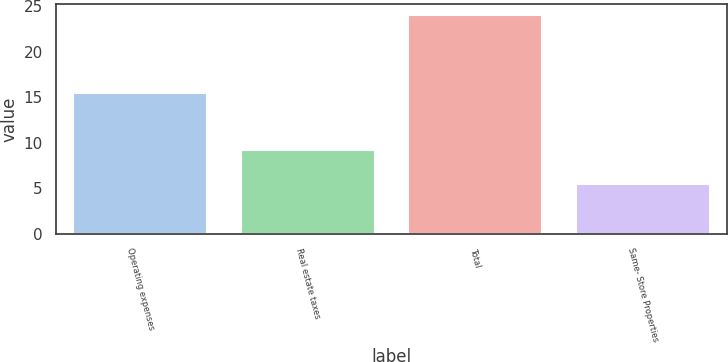<chart> <loc_0><loc_0><loc_500><loc_500><bar_chart><fcel>Operating expenses<fcel>Real estate taxes<fcel>Total<fcel>Same- Store Properties<nl><fcel>15.4<fcel>9.2<fcel>24<fcel>5.5<nl></chart> 